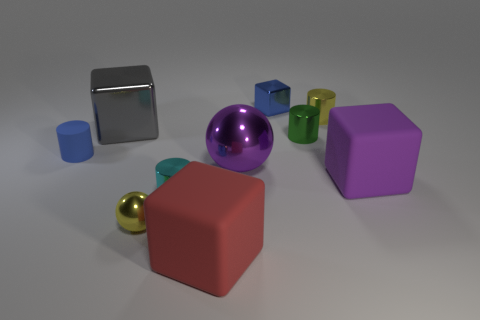What is the color of the thing that is on the right side of the yellow object behind the tiny matte cylinder?
Offer a very short reply. Purple. What size is the block that is both right of the purple metal sphere and to the left of the big purple matte cube?
Provide a short and direct response. Small. Is there any other thing that has the same color as the big metal cube?
Give a very brief answer. No. What is the shape of the large purple object that is made of the same material as the small block?
Make the answer very short. Sphere. Does the blue metallic thing have the same shape as the big thing left of the tiny cyan metal cylinder?
Offer a very short reply. Yes. What material is the yellow object left of the cylinder in front of the matte cylinder?
Offer a terse response. Metal. Are there the same number of tiny rubber cylinders on the right side of the small green cylinder and large gray shiny things?
Provide a succinct answer. No. There is a tiny matte cylinder on the left side of the large red cube; is it the same color as the metal cube that is to the right of the red rubber block?
Ensure brevity in your answer.  Yes. What number of tiny yellow metallic objects are right of the small ball and in front of the gray thing?
Provide a succinct answer. 0. How many other things are the same shape as the small green object?
Keep it short and to the point. 3. 